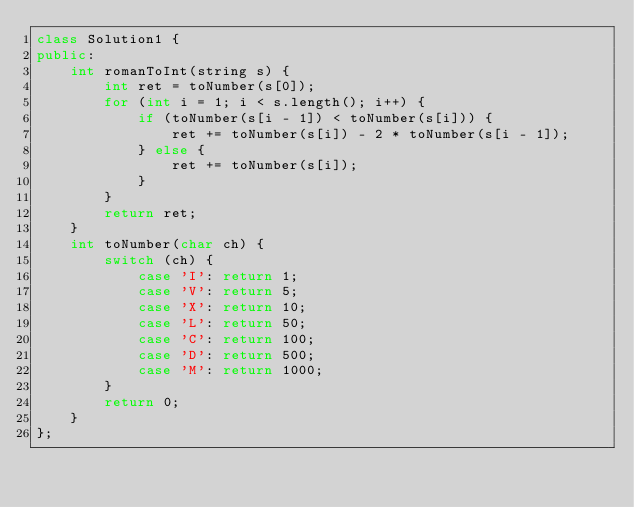Convert code to text. <code><loc_0><loc_0><loc_500><loc_500><_C++_>class Solution1 {
public:
    int romanToInt(string s) {
        int ret = toNumber(s[0]);
        for (int i = 1; i < s.length(); i++) {
            if (toNumber(s[i - 1]) < toNumber(s[i])) {
                ret += toNumber(s[i]) - 2 * toNumber(s[i - 1]);
            } else {
                ret += toNumber(s[i]);
            }
        }
        return ret;
    }
    int toNumber(char ch) {
        switch (ch) {
            case 'I': return 1;
            case 'V': return 5;
            case 'X': return 10;
            case 'L': return 50;
            case 'C': return 100;
            case 'D': return 500;
            case 'M': return 1000;
        }
        return 0;
    }
};
</code> 